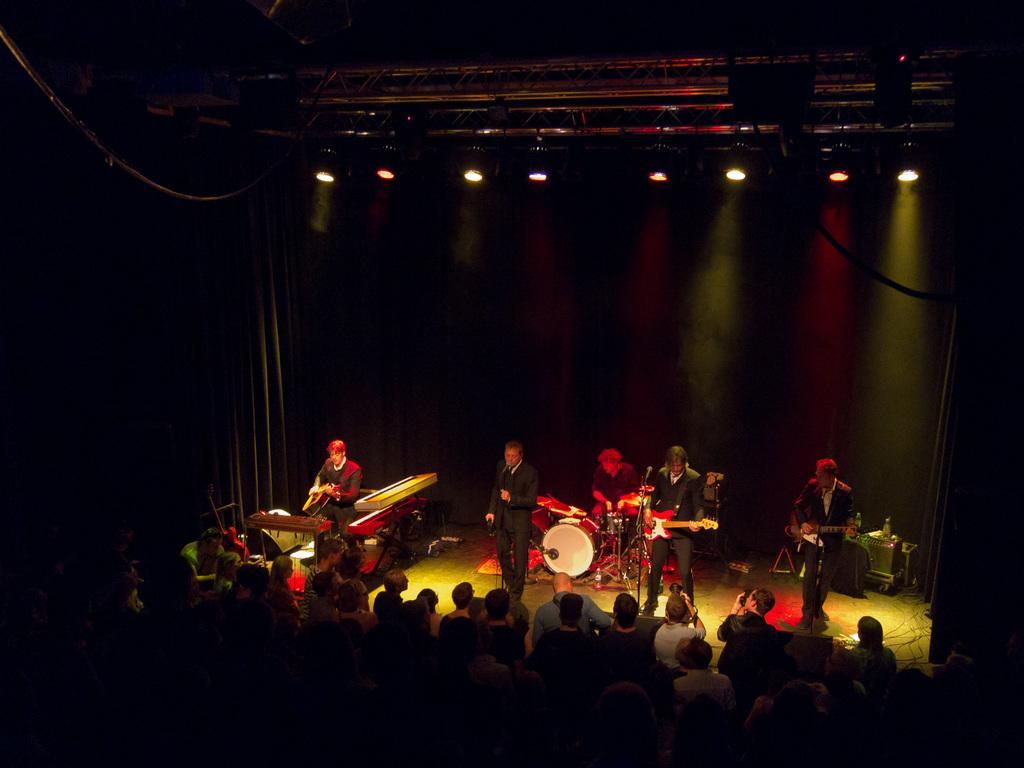In one or two sentences, can you explain what this image depicts? In this image we can see this three persons are holding a guitar in their hands and playing it. This person is playing electronic drums. This person is singing through the mic. There are many people in front of the stage. 